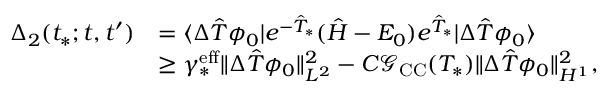Convert formula to latex. <formula><loc_0><loc_0><loc_500><loc_500>\begin{array} { r l } { \Delta _ { 2 } ( t _ { * } ; t , t ^ { \prime } ) } & { = \langle \Delta \hat { T } \phi _ { 0 } | e ^ { - \hat { T } _ { * } } ( \hat { H } - E _ { 0 } ) e ^ { \hat { T } _ { * } } | \Delta \hat { T } \phi _ { 0 } \rangle } \\ & { \geq \gamma _ { * } ^ { e f f } \| \Delta \hat { T } \phi _ { 0 } \| _ { L ^ { 2 } } ^ { 2 } - C \mathcal { G } _ { C C } ( T _ { * } ) \| \Delta \hat { T } \phi _ { 0 } \| _ { H ^ { 1 } } ^ { 2 } , } \end{array}</formula> 